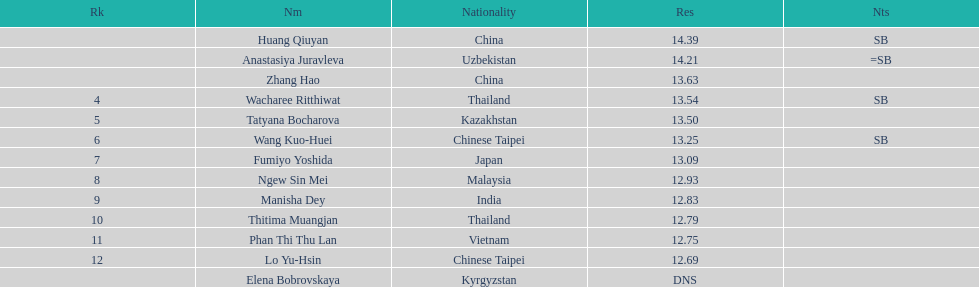How many people were ranked? 12. 